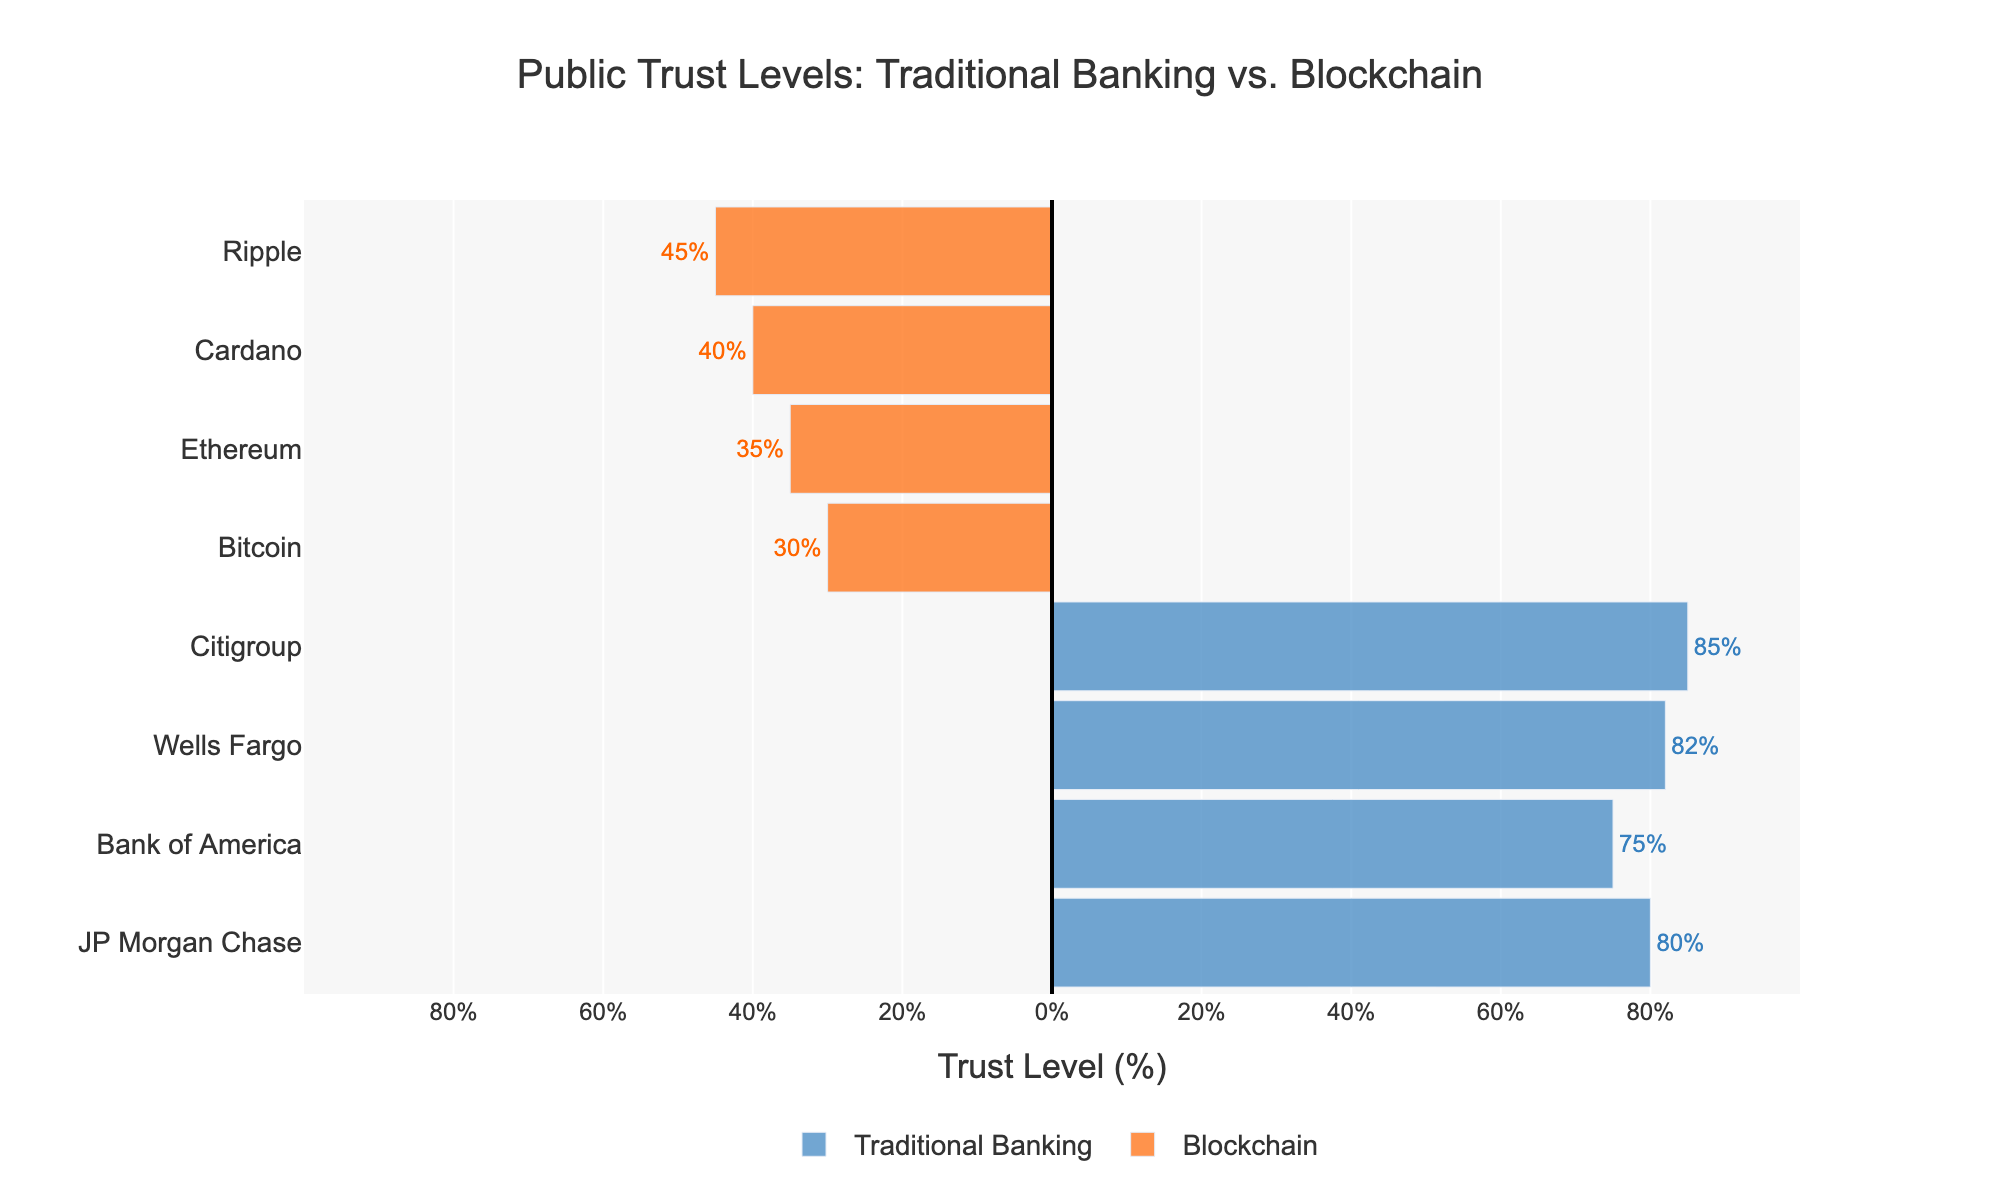What's the difference in trust levels between Citigroup and Bitcoin? Citigroup has a trust level of 85%, while Bitcoin has a trust level of 30%. The difference is calculated as 85% - 30% = 55%.
Answer: 55% Which entity has the lowest trust level in blockchain-based financial systems? By examining the figure, it's clear that Bitcoin has the lowest trust level among blockchain entities with 30%.
Answer: Bitcoin What is the average trust level of traditional banking entities? Traditional banking entities (JP Morgan Chase, Bank of America, Wells Fargo, Citigroup) have trust levels of 80%, 75%, 82%, and 85% respectively. The average trust level is calculated as (80 + 75 + 82 + 85) / 4 = 80.5%.
Answer: 80.5% How much higher is Citigroup's trust level compared to Ripple's? Citigroup's trust level is 85%, and Ripple's trust level is 45%. The difference is 85% - 45% = 40%.
Answer: 40% Are there any entities with trust levels above 80%? Yes, both JP Morgan Chase (80%), Wells Fargo (82%), and Citigroup (85%) have trust levels above 80%.
Answer: Yes What is the total trust level for all blockchain entities combined? The trust levels for blockchain entities (Bitcoin, Ethereum, Cardano, Ripple) are 30%, 35%, 40%, and 45%. The total trust level is calculated as 30 + 35 + 40 + 45 = 150%.
Answer: 150% Which has a higher average trust level: traditional banking or blockchain-based financial systems? Average trust level for traditional banking: (80 + 75 + 82 + 85) / 4 = 80.5%. Average trust level for blockchain: (30 + 35 + 40 + 45) / 4 = 37.5%. Traditional banking has a higher average trust level.
Answer: Traditional banking What is the trust level range among blockchain entities? The trust levels for blockchain entities range from Bitcoin's 30% to Ripple's 45%. The range is 45% - 30% = 15%.
Answer: 15% 